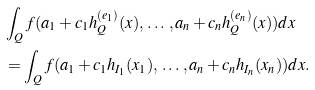<formula> <loc_0><loc_0><loc_500><loc_500>& \int _ { Q } f ( a _ { 1 } + c _ { 1 } h _ { Q } ^ { ( e _ { 1 } ) } ( x ) , \, \dots \, , a _ { n } + c _ { n } h _ { Q } ^ { ( e _ { n } ) } ( x ) ) d x \\ & = \int _ { Q } f ( a _ { 1 } + c _ { 1 } h _ { I _ { 1 } } ( x _ { 1 } ) , \, \dots \, , a _ { n } + c _ { n } h _ { I _ { n } } ( x _ { n } ) ) d x .</formula> 